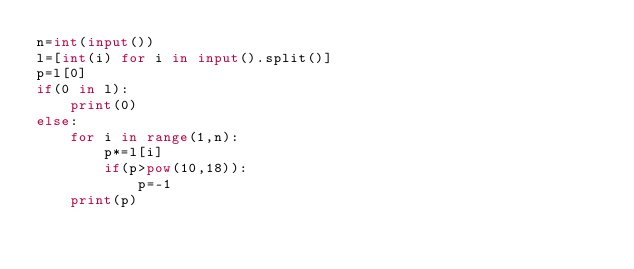Convert code to text. <code><loc_0><loc_0><loc_500><loc_500><_Python_>n=int(input())
l=[int(i) for i in input().split()]
p=l[0]
if(0 in l):
    print(0)
else:
    for i in range(1,n):
        p*=l[i]
        if(p>pow(10,18)):
            p=-1
    print(p)</code> 